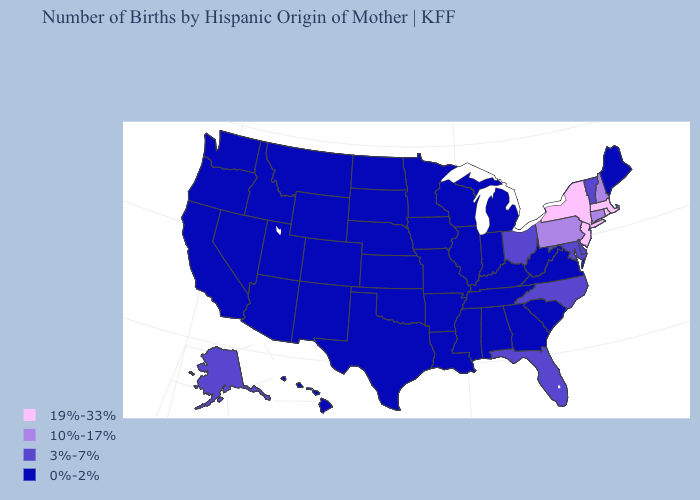What is the value of Connecticut?
Short answer required. 10%-17%. Does Virginia have the highest value in the USA?
Answer briefly. No. Name the states that have a value in the range 0%-2%?
Write a very short answer. Alabama, Arizona, Arkansas, California, Colorado, Georgia, Hawaii, Idaho, Illinois, Indiana, Iowa, Kansas, Kentucky, Louisiana, Maine, Michigan, Minnesota, Mississippi, Missouri, Montana, Nebraska, Nevada, New Mexico, North Dakota, Oklahoma, Oregon, South Carolina, South Dakota, Tennessee, Texas, Utah, Virginia, Washington, West Virginia, Wisconsin, Wyoming. Which states hav the highest value in the West?
Keep it brief. Alaska. Does the map have missing data?
Concise answer only. No. Does the first symbol in the legend represent the smallest category?
Give a very brief answer. No. Name the states that have a value in the range 3%-7%?
Write a very short answer. Alaska, Delaware, Florida, Maryland, North Carolina, Ohio, Vermont. What is the lowest value in states that border Ohio?
Keep it brief. 0%-2%. Name the states that have a value in the range 3%-7%?
Keep it brief. Alaska, Delaware, Florida, Maryland, North Carolina, Ohio, Vermont. What is the value of North Dakota?
Quick response, please. 0%-2%. Among the states that border New Jersey , which have the highest value?
Quick response, please. New York. Name the states that have a value in the range 19%-33%?
Keep it brief. Massachusetts, New Jersey, New York, Rhode Island. Does Kentucky have the same value as Maryland?
Concise answer only. No. Name the states that have a value in the range 3%-7%?
Answer briefly. Alaska, Delaware, Florida, Maryland, North Carolina, Ohio, Vermont. 